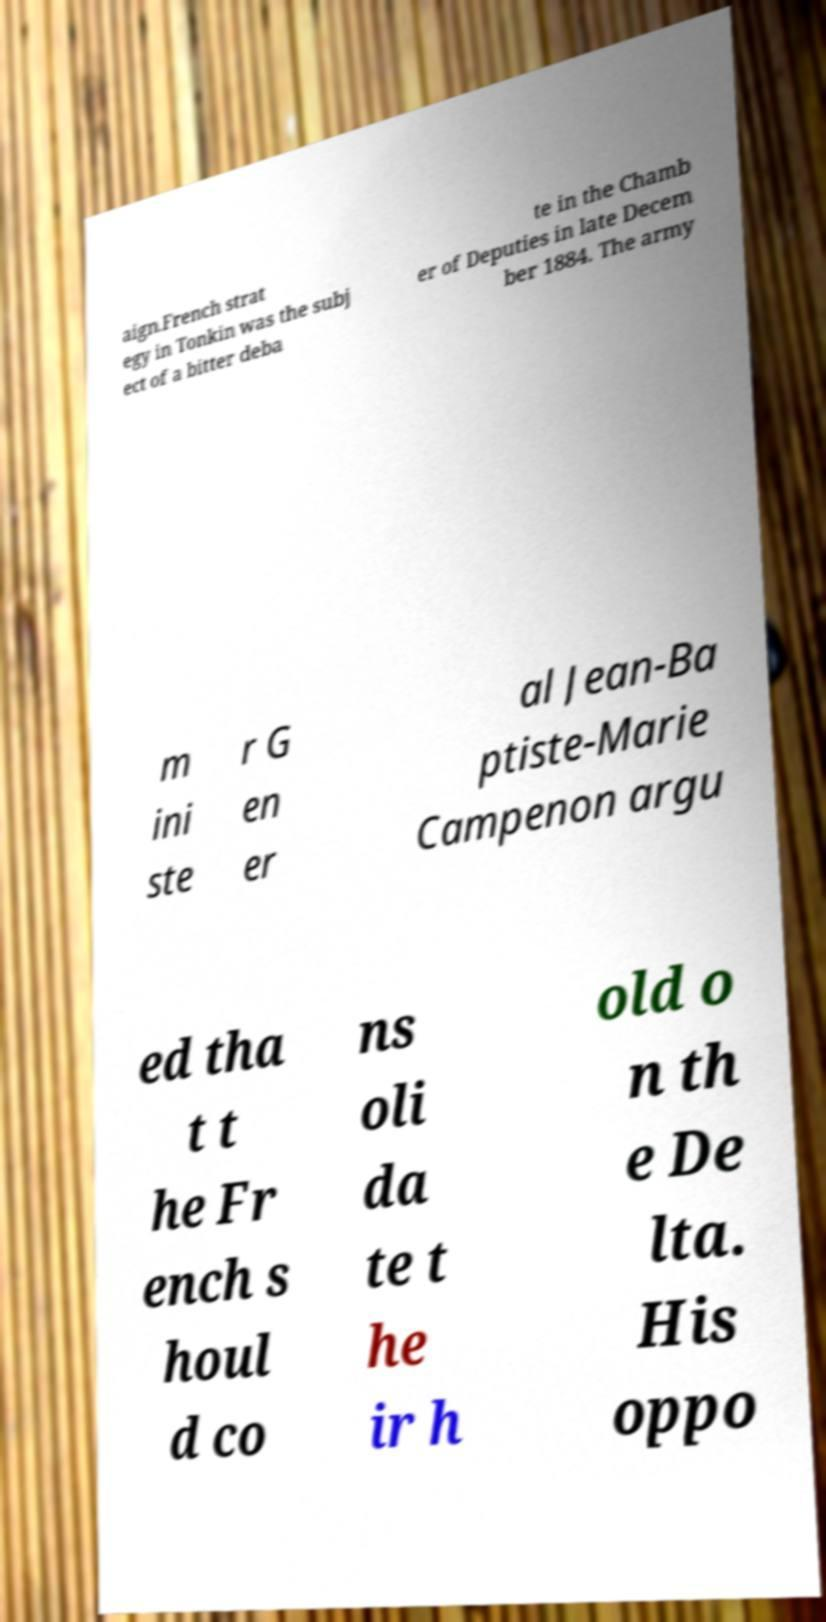Can you accurately transcribe the text from the provided image for me? aign.French strat egy in Tonkin was the subj ect of a bitter deba te in the Chamb er of Deputies in late Decem ber 1884. The army m ini ste r G en er al Jean-Ba ptiste-Marie Campenon argu ed tha t t he Fr ench s houl d co ns oli da te t he ir h old o n th e De lta. His oppo 